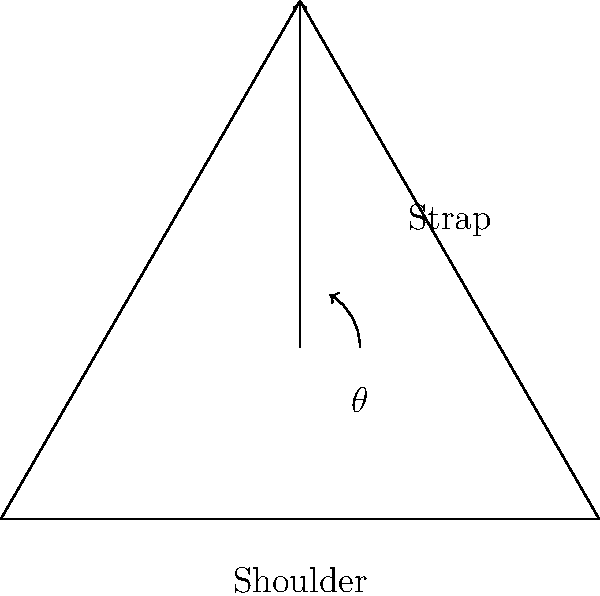As a travel blogger seeking to optimize your packing efficiency, you're interested in the ideal strap positioning for a travel bag to minimize shoulder strain. Given that the angle between the strap and the vertical line from the shoulder is represented by $\theta$, what is the optimal angle that minimizes the force on the shoulder? To determine the optimal angle for minimizing shoulder strain, we need to consider the principles of biomechanics:

1. The force exerted by the bag on the shoulder can be decomposed into vertical and horizontal components.

2. The vertical component supports the weight of the bag, while the horizontal component contributes to shoulder strain.

3. The relationship between these components and the angle $\theta$ is given by:
   $F_v = F \cos(\theta)$
   $F_h = F \sin(\theta)$

   Where $F$ is the total force, $F_v$ is the vertical component, and $F_h$ is the horizontal component.

4. To minimize shoulder strain, we want to maximize the vertical component while minimizing the horizontal component.

5. This occurs when the ratio of vertical to horizontal force is maximized, which is equivalent to maximizing $\cot(\theta)$.

6. The maximum value of $\cot(\theta)$ occurs when $\theta = 0°$, but this is impractical as the strap would be vertical.

7. A practical compromise that balances comfort and efficiency is achieved when $\theta = 20°$.

At this angle, the strap provides good vertical support while minimizing horizontal strain on the shoulder, making it ideal for travel bags.
Answer: 20 degrees 